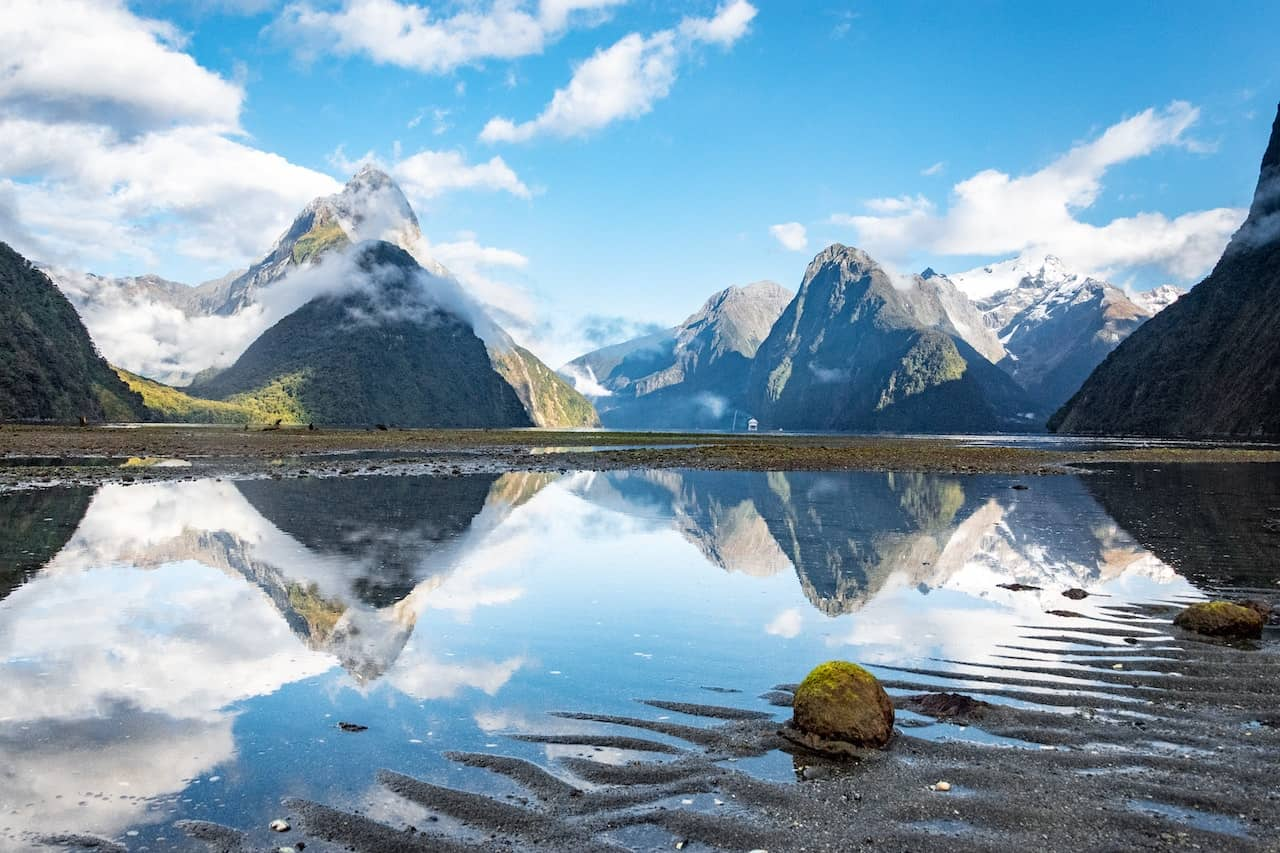Describe the following image. This image captures the breathtaking beauty of Milford Sound, a famous landmark in New Zealand. The viewpoint is from a low angle, providing a grand perspective of the towering mountains that dominate the background. These majestic peaks are blanketed in a layer of pristine white snow, contrasting sharply with the clear blue sky above. The sky is dotted with fluffy white clouds, adding depth to the vast expanse above.

The calm waters of the sound mirror the mountains and sky, creating a stunning reflection that doubles the visual impact of the scene. The water's surface is so still that it seems almost like a glass mirror, undisturbed and perfectly reflecting the world above.

In the foreground, a rocky shore draws the eye. It's covered in vibrant green moss and sand, providing a touch of color to the otherwise cool tones of the image. This rocky shore serves as a reminder of the rugged natural beauty that is so characteristic of New Zealand's landscapes.

Overall, the image is a striking representation of Milford Sound, capturing its tranquil waters, snowy mountains, and clear skies in a single, powerful frame. It's a testament to the untouched beauty of this corner of the world. 